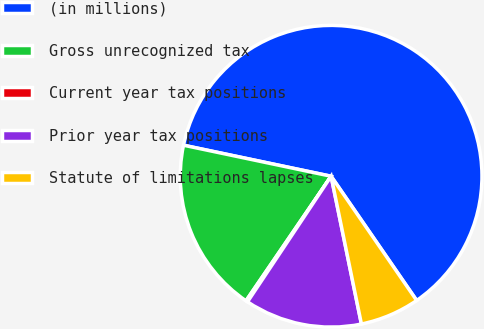Convert chart to OTSL. <chart><loc_0><loc_0><loc_500><loc_500><pie_chart><fcel>(in millions)<fcel>Gross unrecognized tax<fcel>Current year tax positions<fcel>Prior year tax positions<fcel>Statute of limitations lapses<nl><fcel>62.11%<fcel>18.76%<fcel>0.19%<fcel>12.57%<fcel>6.38%<nl></chart> 